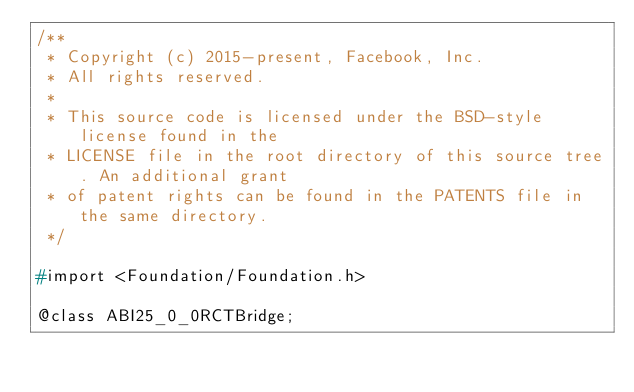Convert code to text. <code><loc_0><loc_0><loc_500><loc_500><_C_>/**
 * Copyright (c) 2015-present, Facebook, Inc.
 * All rights reserved.
 *
 * This source code is licensed under the BSD-style license found in the
 * LICENSE file in the root directory of this source tree. An additional grant
 * of patent rights can be found in the PATENTS file in the same directory.
 */

#import <Foundation/Foundation.h>

@class ABI25_0_0RCTBridge;
</code> 